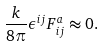<formula> <loc_0><loc_0><loc_500><loc_500>\frac { k } { 8 \pi } \epsilon ^ { i j } F _ { i j } ^ { a } \approx 0 .</formula> 